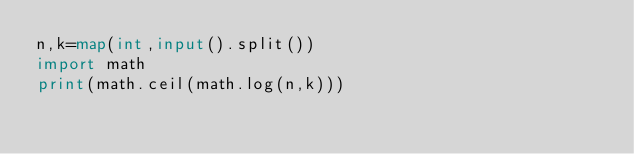Convert code to text. <code><loc_0><loc_0><loc_500><loc_500><_Python_>n,k=map(int,input().split())
import math
print(math.ceil(math.log(n,k)))</code> 